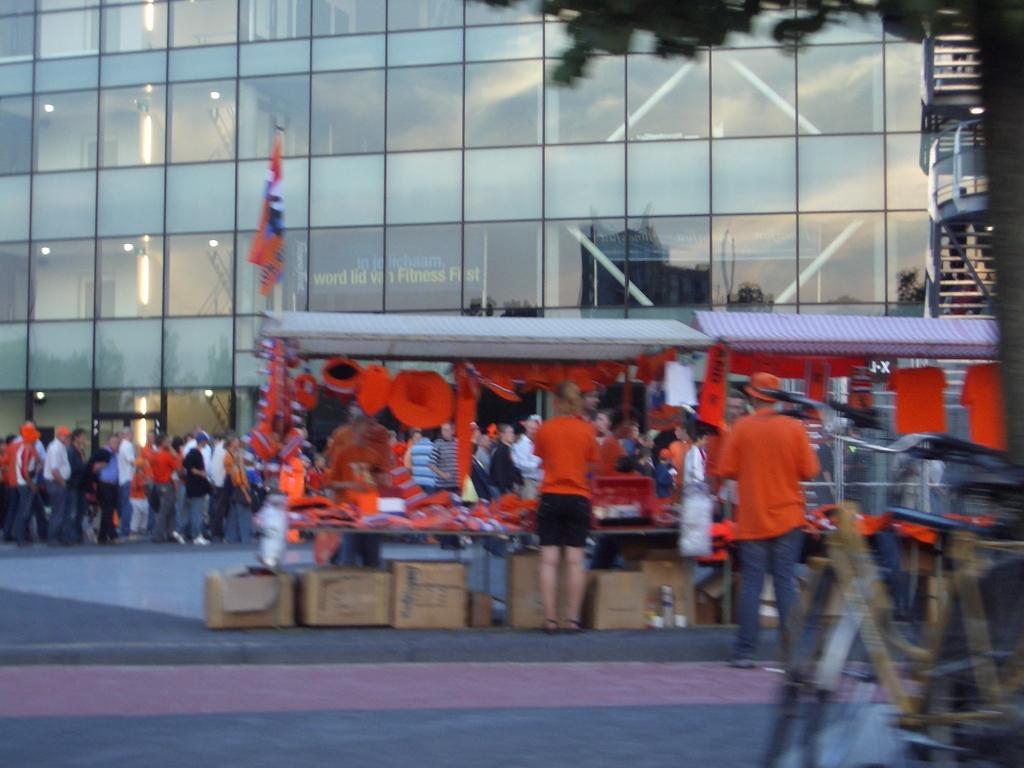Could you give a brief overview of what you see in this image? In this picture I can see the stalls. I can see a number of people on the surface. I can see the building in the background. I can see the bicycles on the right side. 